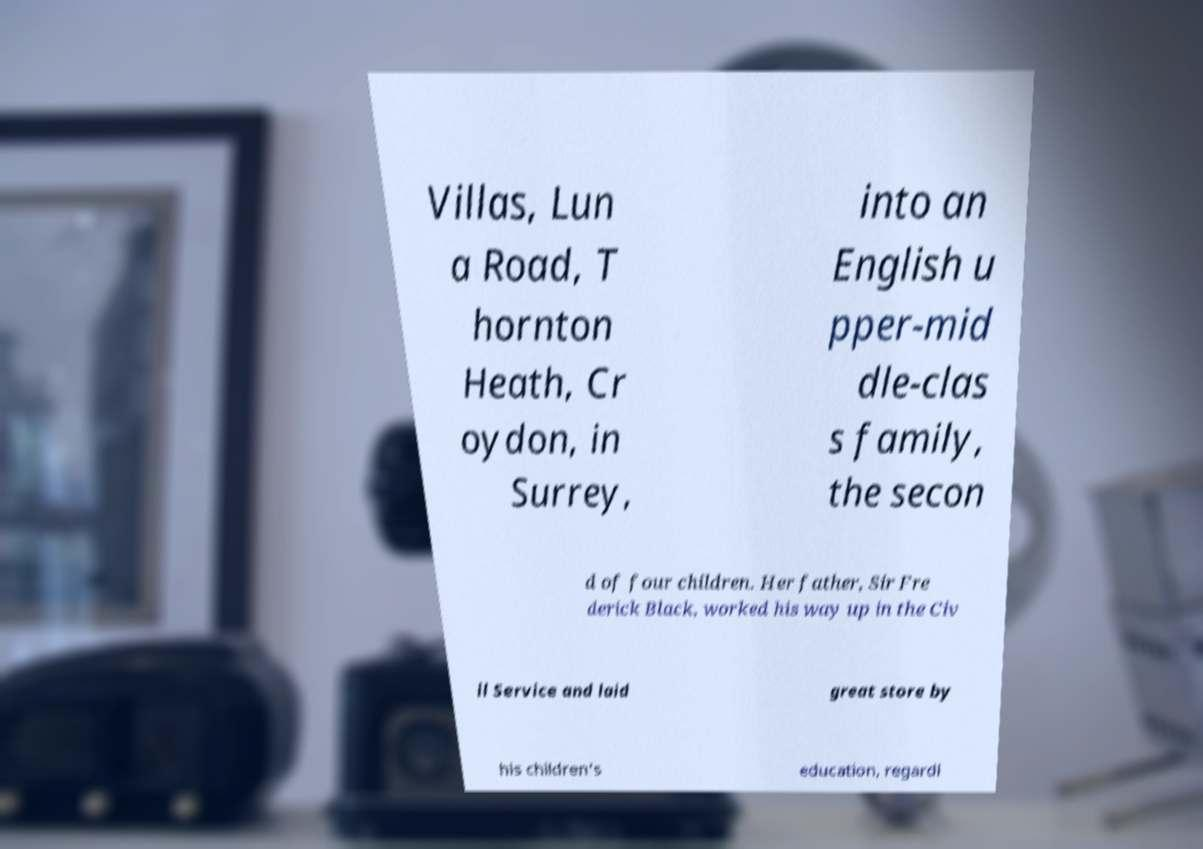What messages or text are displayed in this image? I need them in a readable, typed format. Villas, Lun a Road, T hornton Heath, Cr oydon, in Surrey, into an English u pper-mid dle-clas s family, the secon d of four children. Her father, Sir Fre derick Black, worked his way up in the Civ il Service and laid great store by his children's education, regardl 